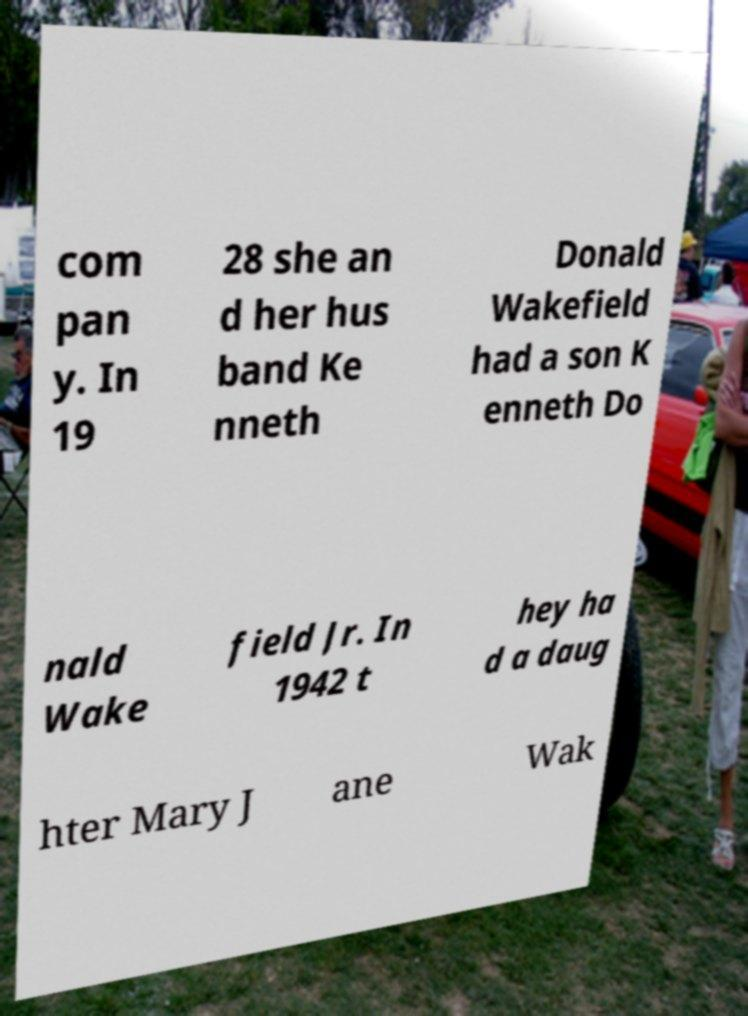Can you read and provide the text displayed in the image?This photo seems to have some interesting text. Can you extract and type it out for me? com pan y. In 19 28 she an d her hus band Ke nneth Donald Wakefield had a son K enneth Do nald Wake field Jr. In 1942 t hey ha d a daug hter Mary J ane Wak 